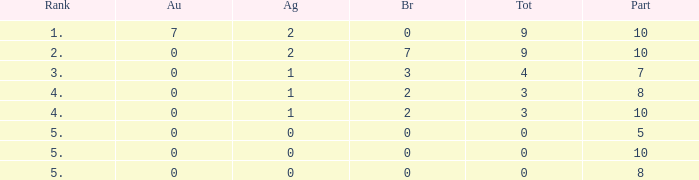What is the overall number of participants with silver quantity smaller than 0? None. 